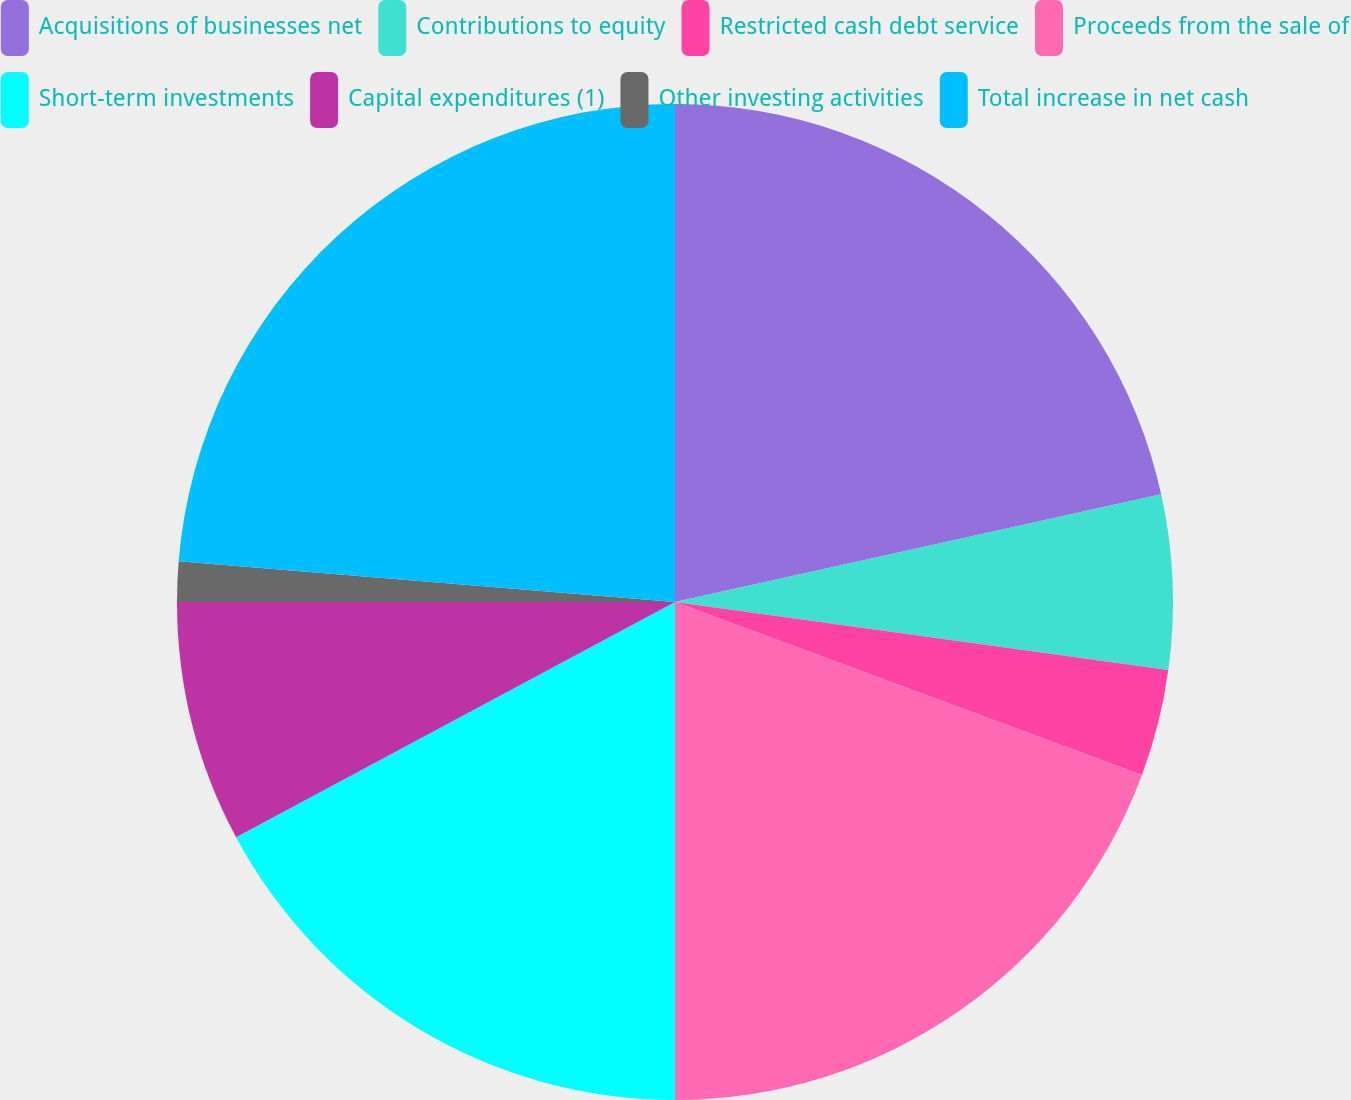<chart> <loc_0><loc_0><loc_500><loc_500><pie_chart><fcel>Acquisitions of businesses net<fcel>Contributions to equity<fcel>Restricted cash debt service<fcel>Proceeds from the sale of<fcel>Short-term investments<fcel>Capital expenditures (1)<fcel>Other investing activities<fcel>Total increase in net cash<nl><fcel>21.53%<fcel>5.65%<fcel>3.47%<fcel>19.35%<fcel>17.17%<fcel>7.83%<fcel>1.3%<fcel>23.7%<nl></chart> 